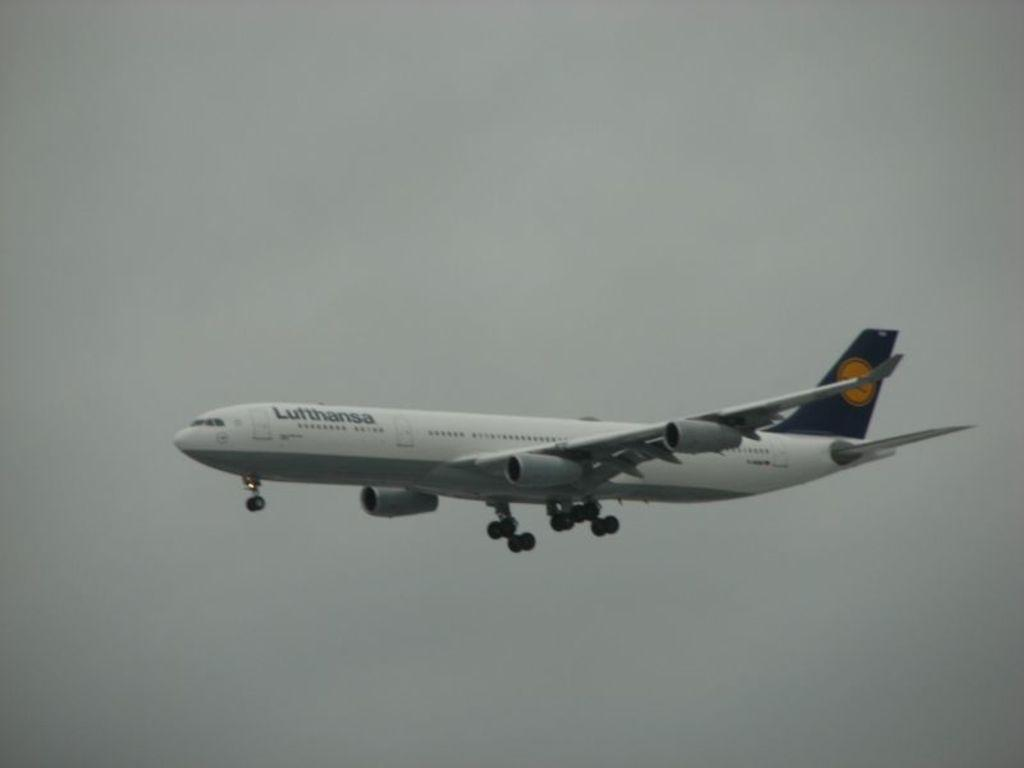What is the main subject of the image? The main subject of the image is an airplane. What type of pipe is being used for business purposes in the image? There is no pipe or business activity present in the image; it features an airplane. What type of crime is being committed in the image? There is no crime or criminal activity present in the image; it features an airplane. 